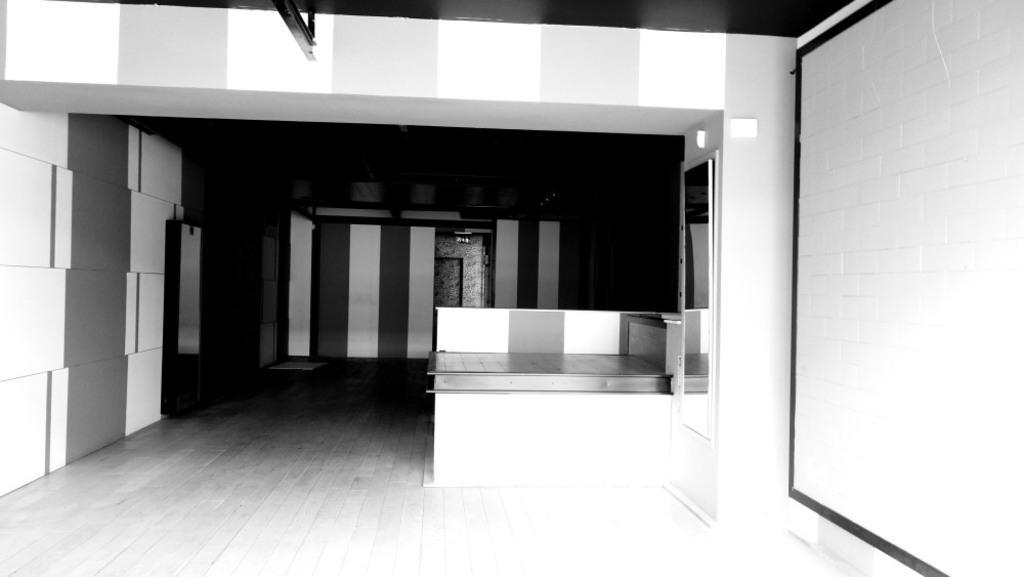In one or two sentences, can you explain what this image depicts? This is a black and white pic. We can see walls, objects, door, floor, table and mirror on the right side wall. 